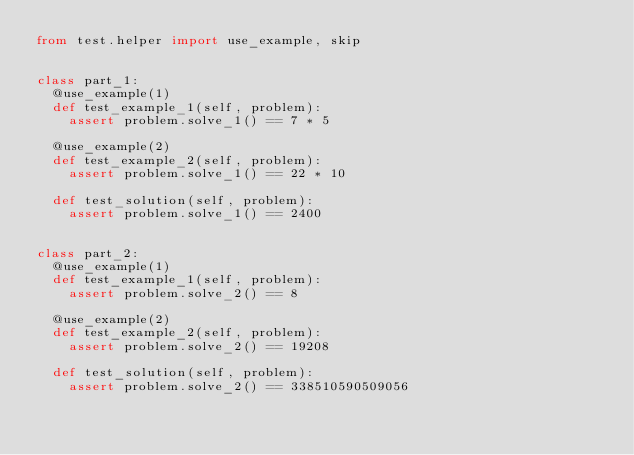Convert code to text. <code><loc_0><loc_0><loc_500><loc_500><_Python_>from test.helper import use_example, skip


class part_1:
  @use_example(1)
  def test_example_1(self, problem):
    assert problem.solve_1() == 7 * 5

  @use_example(2)
  def test_example_2(self, problem):
    assert problem.solve_1() == 22 * 10

  def test_solution(self, problem):
    assert problem.solve_1() == 2400


class part_2:
  @use_example(1)
  def test_example_1(self, problem):
    assert problem.solve_2() == 8

  @use_example(2)
  def test_example_2(self, problem):
    assert problem.solve_2() == 19208

  def test_solution(self, problem):
    assert problem.solve_2() == 338510590509056
</code> 